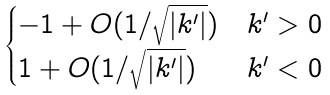Convert formula to latex. <formula><loc_0><loc_0><loc_500><loc_500>\begin{cases} - 1 + O ( 1 / \sqrt { | k ^ { \prime } | } ) & k ^ { \prime } > 0 \\ 1 + O ( 1 / \sqrt { | k ^ { \prime } | } ) & k ^ { \prime } < 0 \end{cases}</formula> 